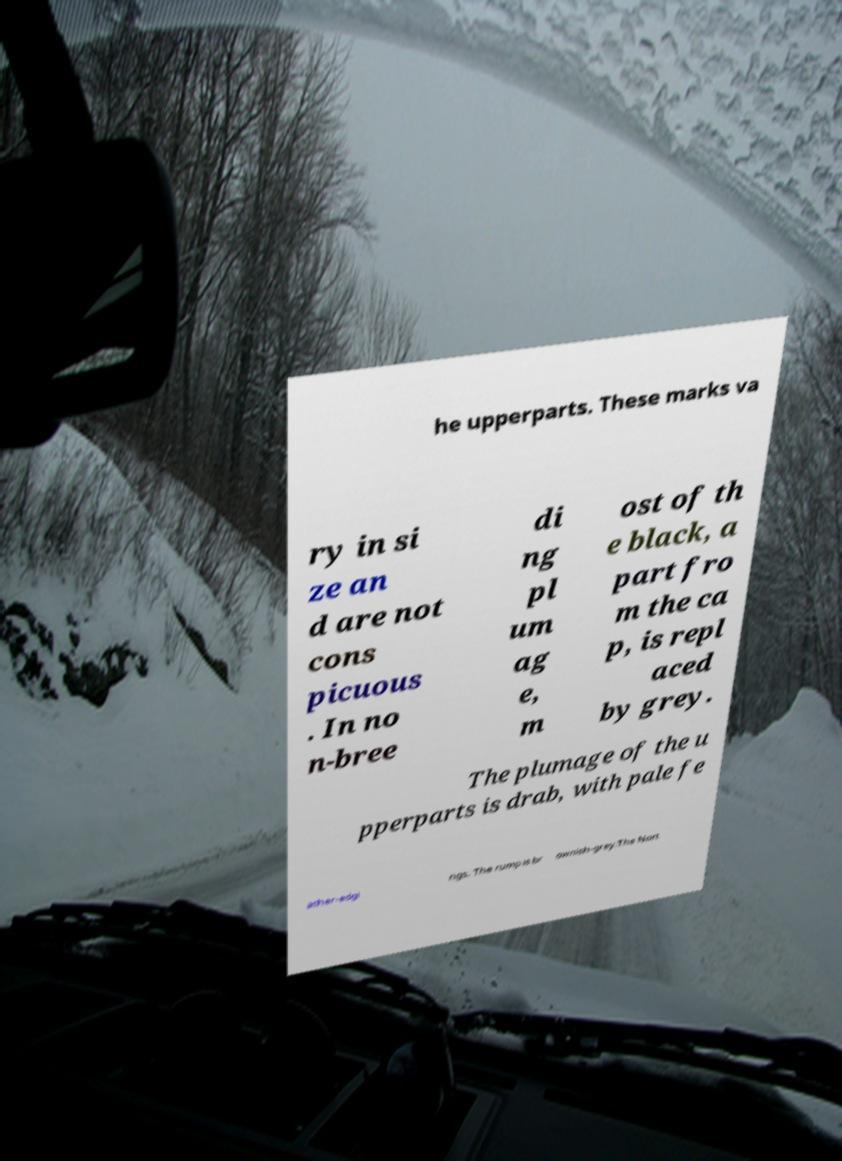Please read and relay the text visible in this image. What does it say? he upperparts. These marks va ry in si ze an d are not cons picuous . In no n-bree di ng pl um ag e, m ost of th e black, a part fro m the ca p, is repl aced by grey. The plumage of the u pperparts is drab, with pale fe ather-edgi ngs. The rump is br ownish-grey.The Nort 